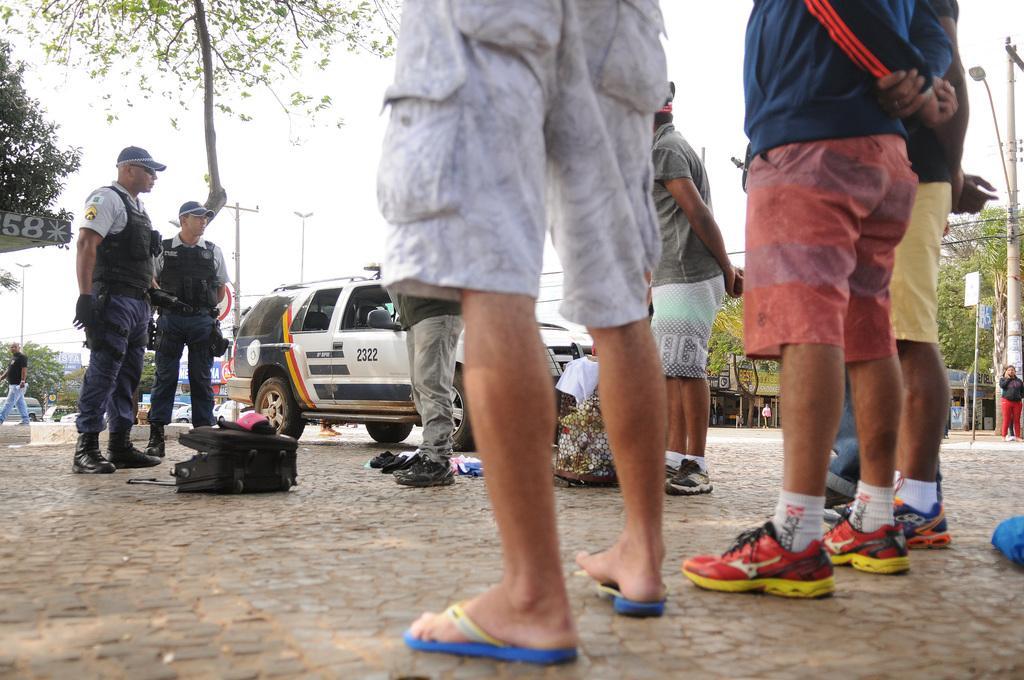Please provide a concise description of this image. In this image we can see few people. There are few objects on the ground. There are few street lights and poles in the image. There are many vehicles in the image. We can see the sky in the image. There are few houses in the image. There are many trees in the image. 